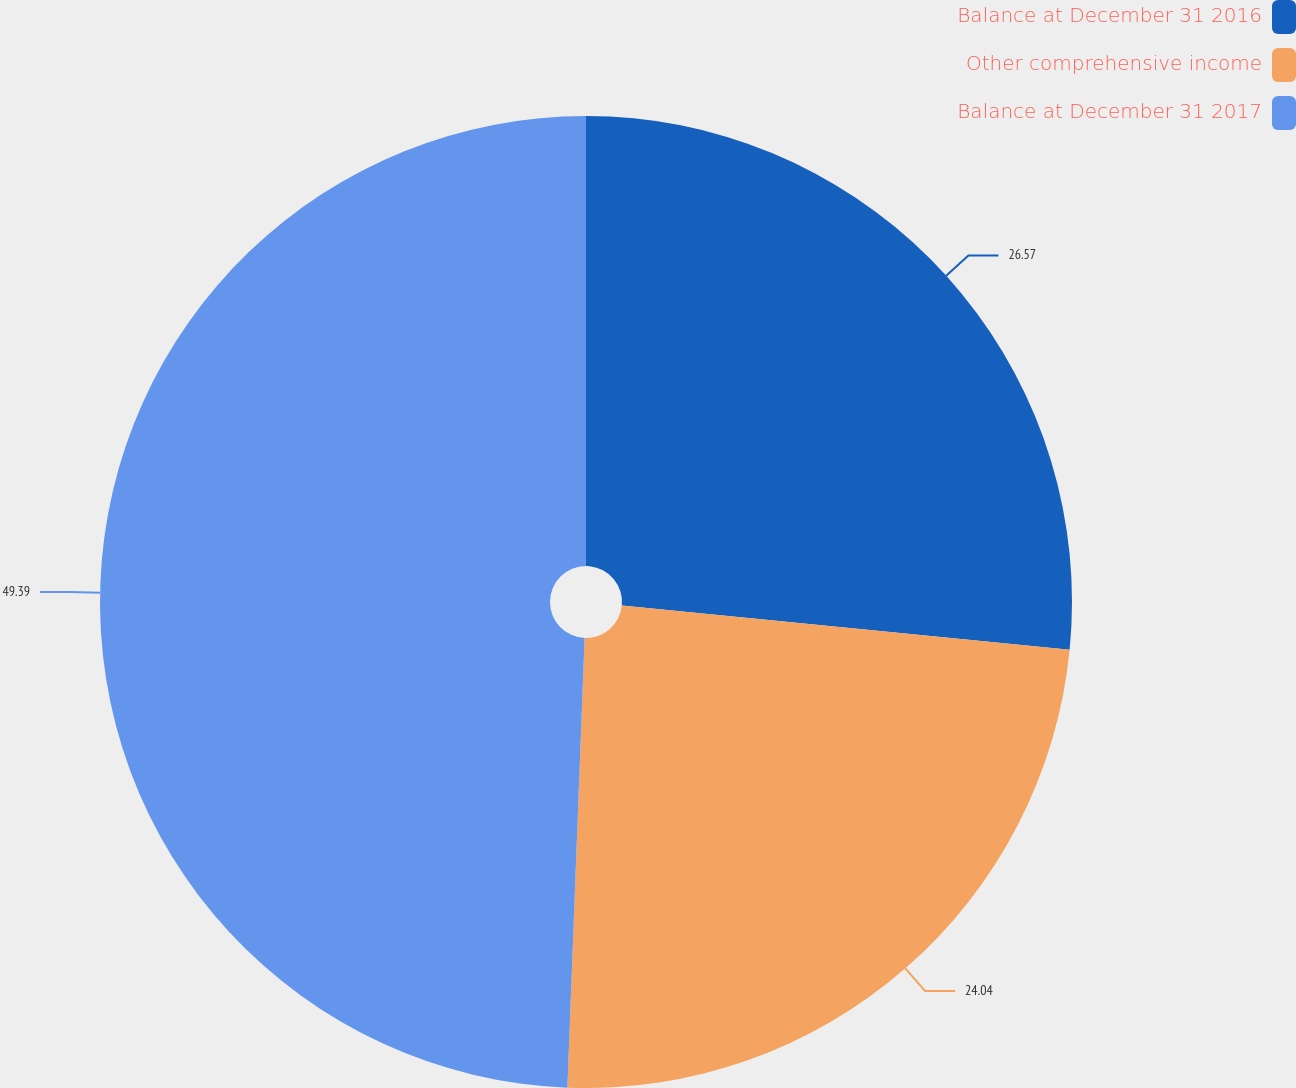<chart> <loc_0><loc_0><loc_500><loc_500><pie_chart><fcel>Balance at December 31 2016<fcel>Other comprehensive income<fcel>Balance at December 31 2017<nl><fcel>26.57%<fcel>24.04%<fcel>49.39%<nl></chart> 